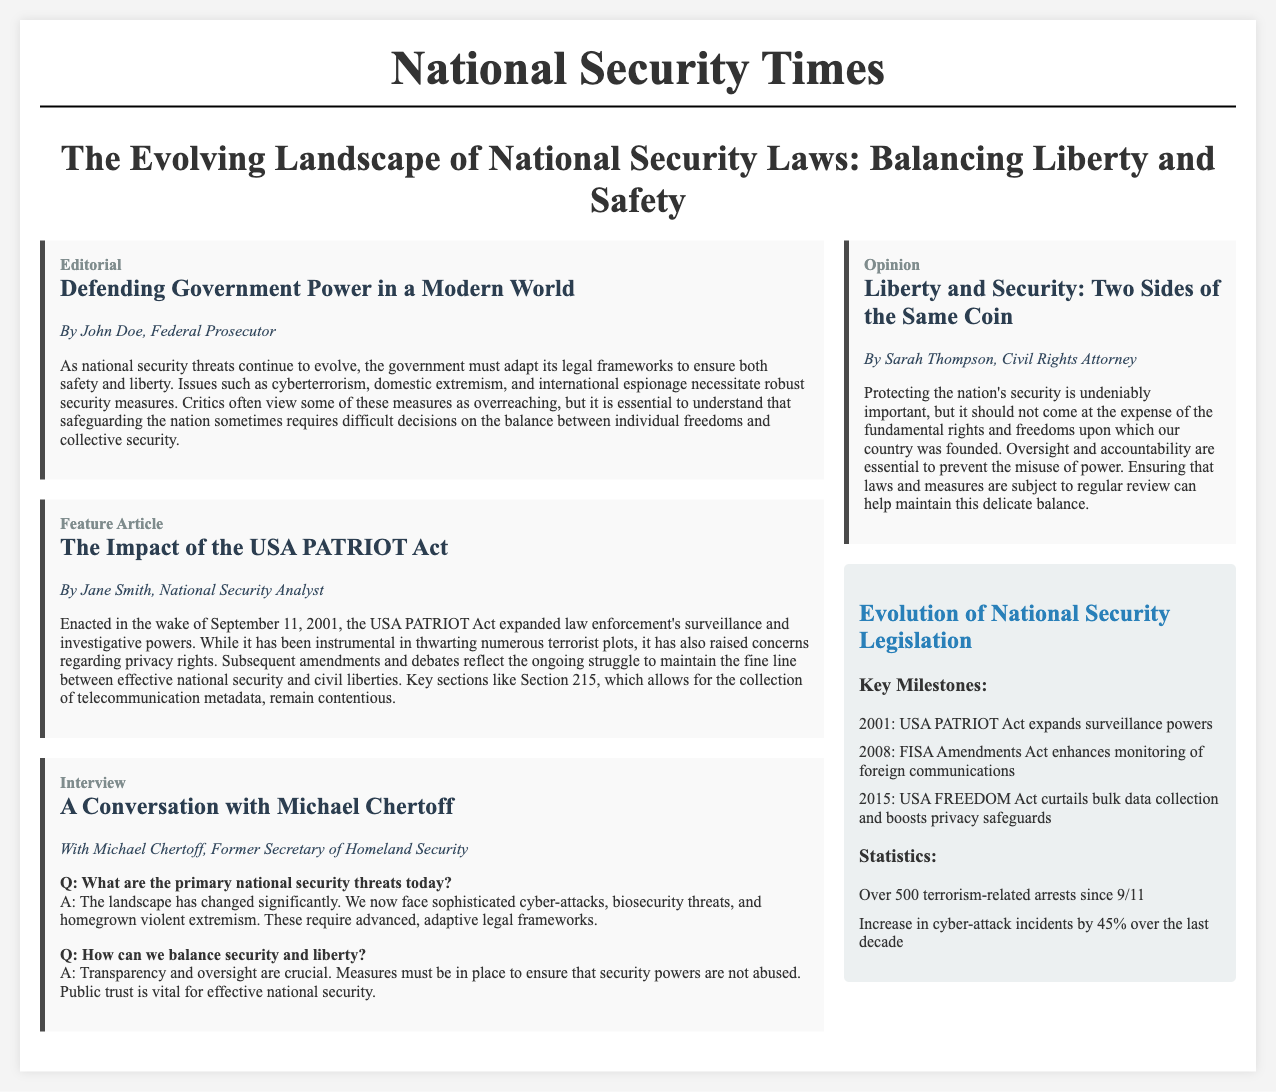What is the title of the editorial? The title of the editorial is clearly stated in the document under the editorial section.
Answer: Defending Government Power in a Modern World Who is the author of the feature article? The author's name is included at the beginning of the feature article section.
Answer: Jane Smith What year was the USA PATRIOT Act enacted? The document provides specific historical context about national security legislation.
Answer: 2001 What percentage increase in cyber-attack incidents is mentioned? The infographic section cites statistics about cyber-attack incidents.
Answer: 45% According to the interview, who is the former Secretary of Homeland Security? The document identifies key individuals in the context of national security measures.
Answer: Michael Chertoff What is emphasized as crucial for balancing security and liberty? The interview highlights important themes related to national security and civil liberties.
Answer: Transparency and oversight What is a key focus of the opinion article? The opinion article provides a subjective perspective on national security laws.
Answer: Oversight and accountability How many terrorism-related arrests have occurred since 9/11? The infographic presents a specific number regarding arrests linked to terrorism.
Answer: Over 500 What act was passed in 2015 according to the infographic? The infographic outlines major legislation relevant to national security laws.
Answer: USA FREEDOM Act 